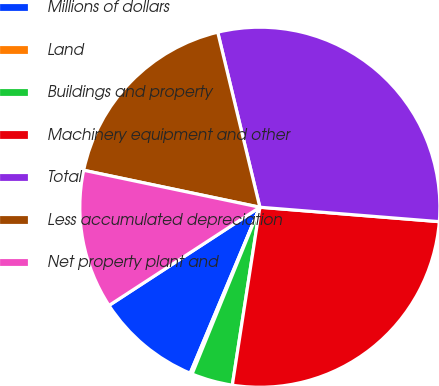<chart> <loc_0><loc_0><loc_500><loc_500><pie_chart><fcel>Millions of dollars<fcel>Land<fcel>Buildings and property<fcel>Machinery equipment and other<fcel>Total<fcel>Less accumulated depreciation<fcel>Net property plant and<nl><fcel>9.49%<fcel>0.18%<fcel>3.7%<fcel>26.17%<fcel>30.04%<fcel>17.95%<fcel>12.48%<nl></chart> 